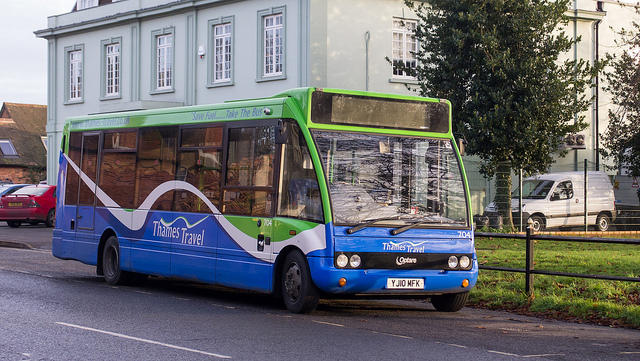Please transcribe the text in this image. Thames Travel 104 HFK Y 